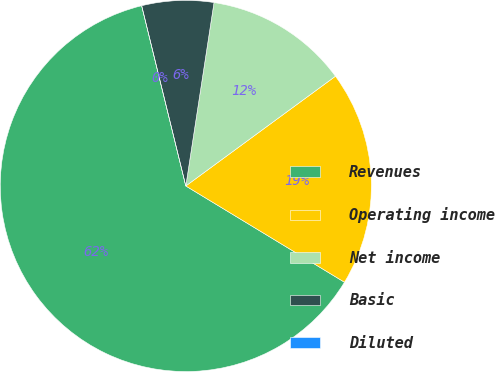Convert chart to OTSL. <chart><loc_0><loc_0><loc_500><loc_500><pie_chart><fcel>Revenues<fcel>Operating income<fcel>Net income<fcel>Basic<fcel>Diluted<nl><fcel>62.5%<fcel>18.75%<fcel>12.5%<fcel>6.25%<fcel>0.0%<nl></chart> 